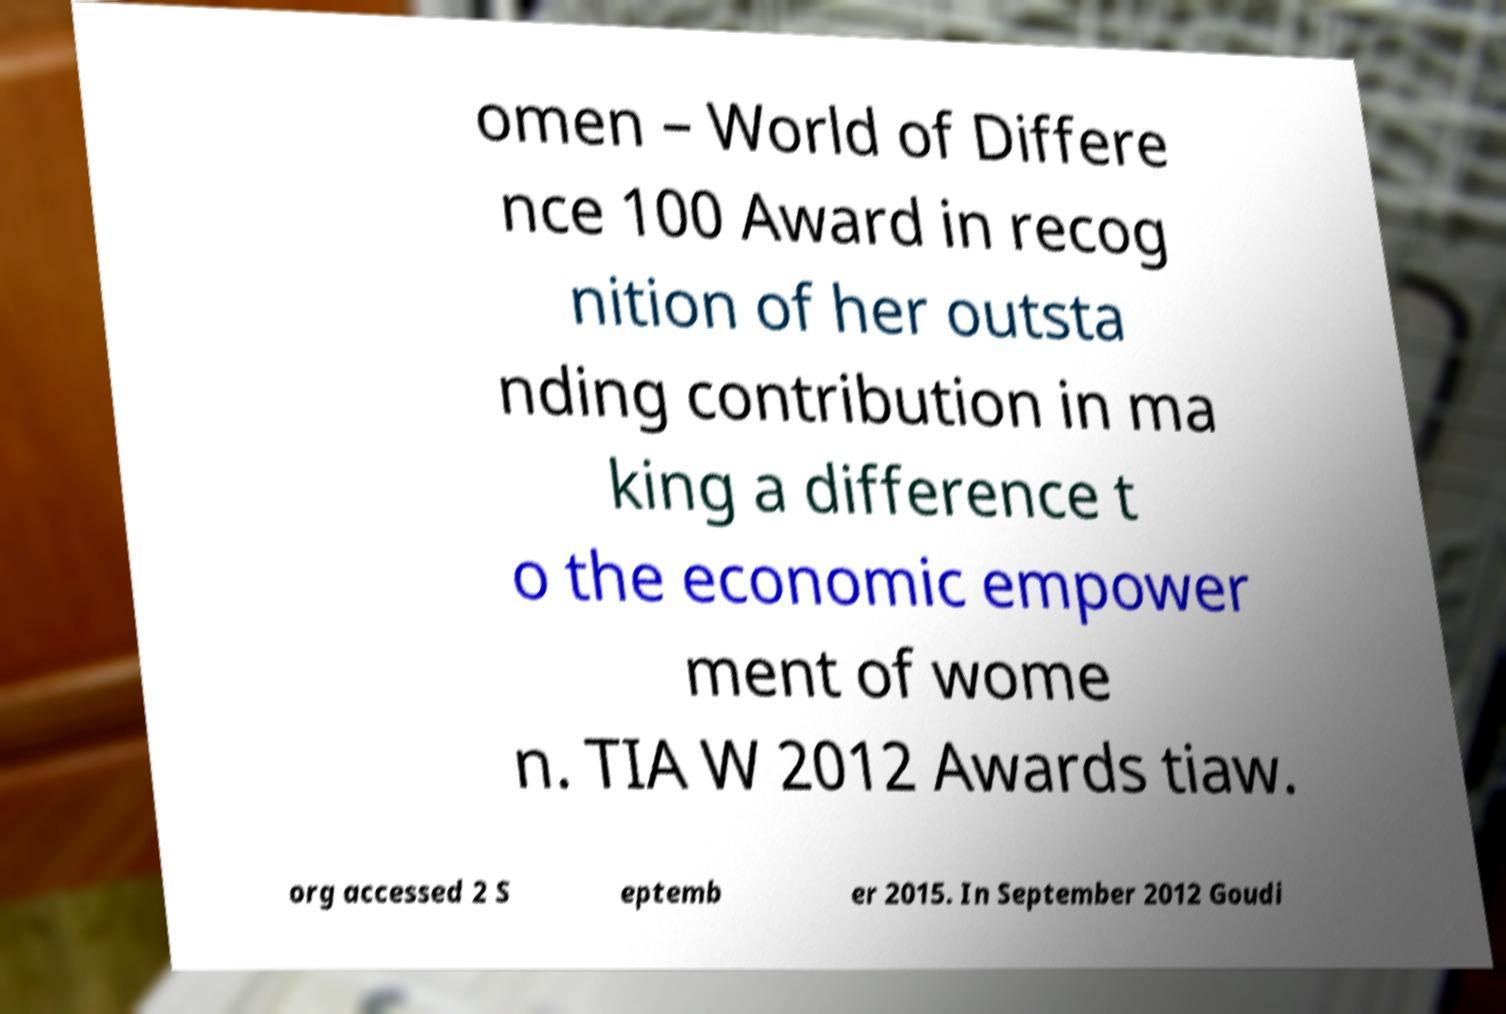Could you extract and type out the text from this image? omen – World of Differe nce 100 Award in recog nition of her outsta nding contribution in ma king a difference t o the economic empower ment of wome n. TIA W 2012 Awards tiaw. org accessed 2 S eptemb er 2015. In September 2012 Goudi 